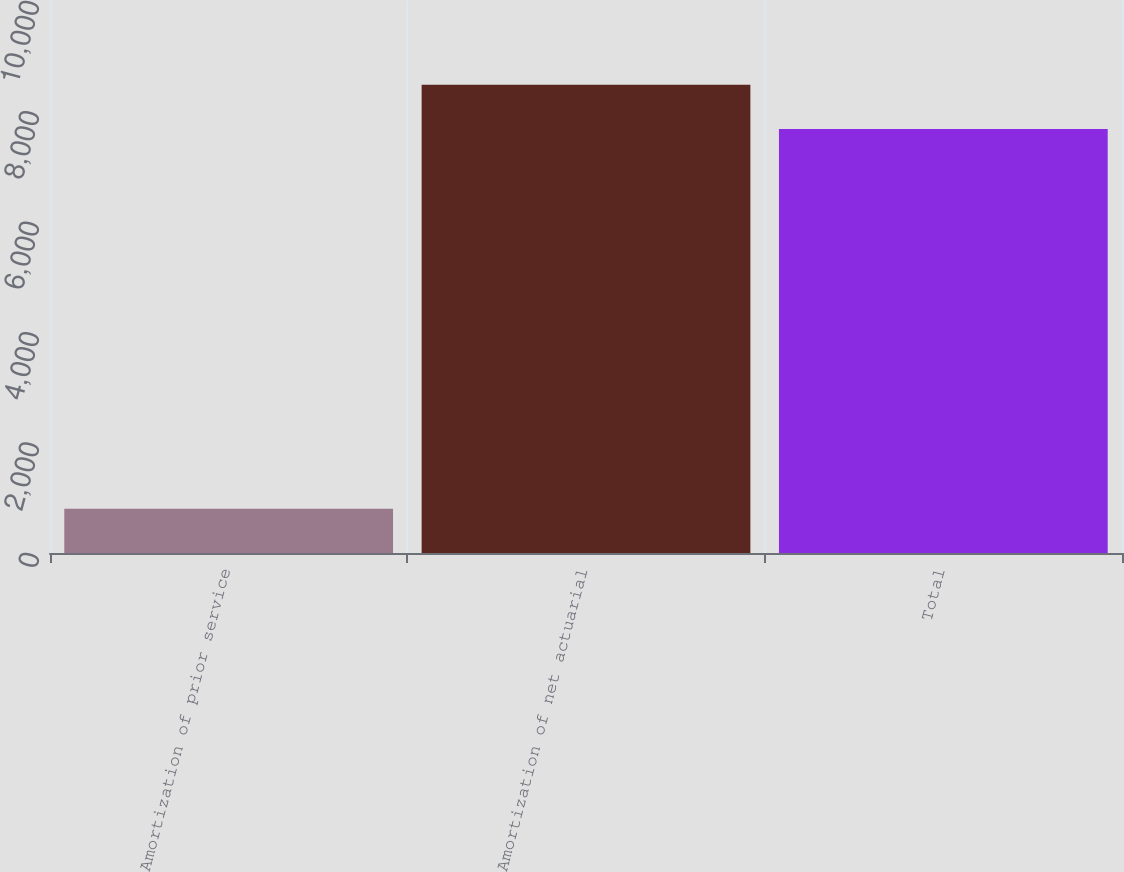Convert chart. <chart><loc_0><loc_0><loc_500><loc_500><bar_chart><fcel>Amortization of prior service<fcel>Amortization of net actuarial<fcel>Total<nl><fcel>801<fcel>8484<fcel>7683<nl></chart> 